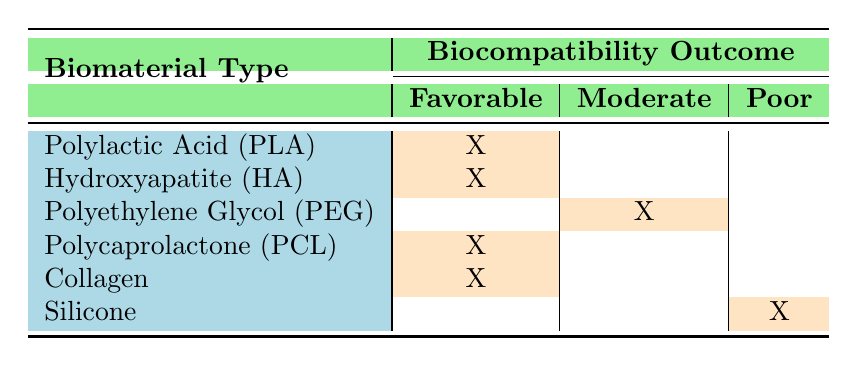What biomaterial types have a favorable biocompatibility outcome? The table lists the biomaterials with a favorable outcome marked with an "X" under the "Favorable" column. These materials are Polylactic Acid (PLA), Hydroxyapatite (HA), Polycaprolactone (PCL), and Collagen.
Answer: Polylactic Acid, Hydroxyapatite, Polycaprolactone, Collagen Is there any biomaterial type associated with a poor biocompatibility outcome? Based on the table, Silicone is the only biomaterial that has an "X" under the "Poor" column, indicating a poor biocompatibility outcome.
Answer: Yes How many biomaterials show a moderate biocompatibility outcome? The table shows that only one biomaterial, Polyethylene Glycol (PEG), is marked with an "X" under the "Moderate" column.
Answer: 1 Which biomaterial type has the best overall biocompatibility outcome? The best overall outcomes are categorized under "Favorable." The table indicates that 4 different biomaterials (PLA, HA, PCL, and Collagen) fall under this outcome, signifying their comparatively better biocompatibility.
Answer: Polylactic Acid, Hydroxyapatite, Polycaprolactone, Collagen Are animal studies associated with any biomaterials that have poor outcomes? By reviewing the table, we see that all biomaterials associated with the "Poor" outcome (Silicone) come from human clinical trials, while animal studies show only favorable or moderate outcomes.
Answer: No What is the difference in the number of favorable versus poor biocompatibility outcomes? Counting the outcomes in the table, there are 4 favorable outcomes (PLA, HA, PCL, Collagen) and 1 poor outcome (Silicone). The difference is 4 (favorable) - 1 (poor) = 3.
Answer: 3 Which biomaterial type has the least favorable outcome? The least favorable outcome according to the table is associated with Silicone, which falls under the "Poor" category.
Answer: Silicone How many biomaterials have been tested on human populations? From the table, Hydroxyapatite (HA), Polycaprolactone (PCL), and Silicone are the biomaterials listed under "Human Clinical Trial," making a total of 3.
Answer: 3 What trend is observed regarding the types of biocompatibility outcomes in animal studies as compared to human trials? The table indicates that all listed biomaterials in animal studies show favorable or moderate outcomes, while the human trials include one biomaterial (Silicone) with a poor outcome, suggesting animal studies have a more favorable trend.
Answer: Favorable trend in animal studies 